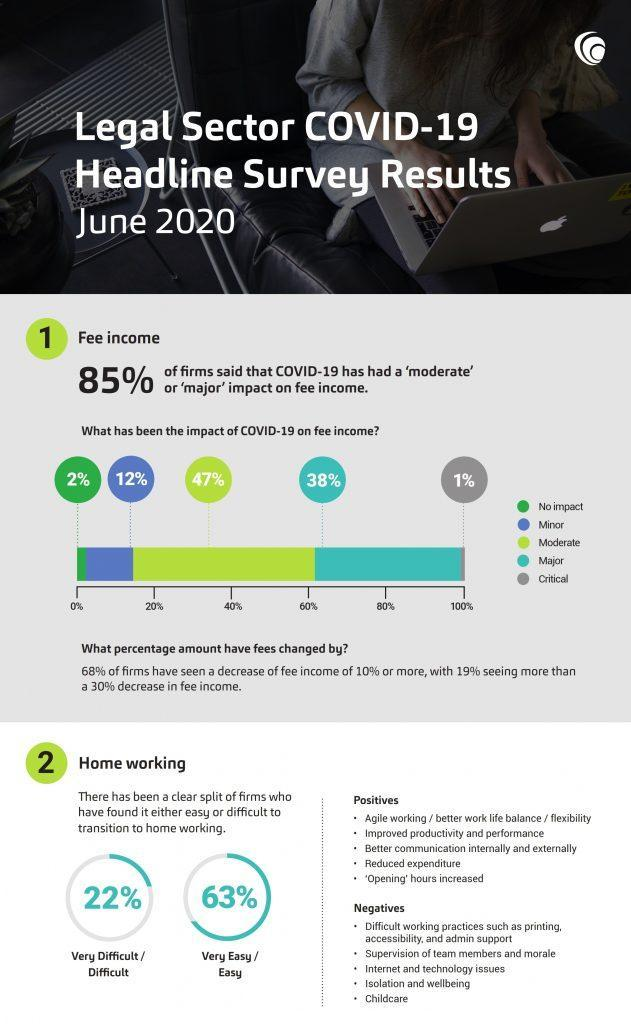Is agile working a positive or negative impact of home working
Answer the question with a short phrase. positive what is the total % who have had a minor or moderate impact on fee income 59 How many have found home working very difficult /difficult 22% what is the total % who have had a major or critical impact on fee income 39 